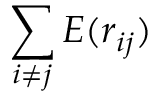Convert formula to latex. <formula><loc_0><loc_0><loc_500><loc_500>\sum _ { i \not = j } E ( r _ { i j } )</formula> 